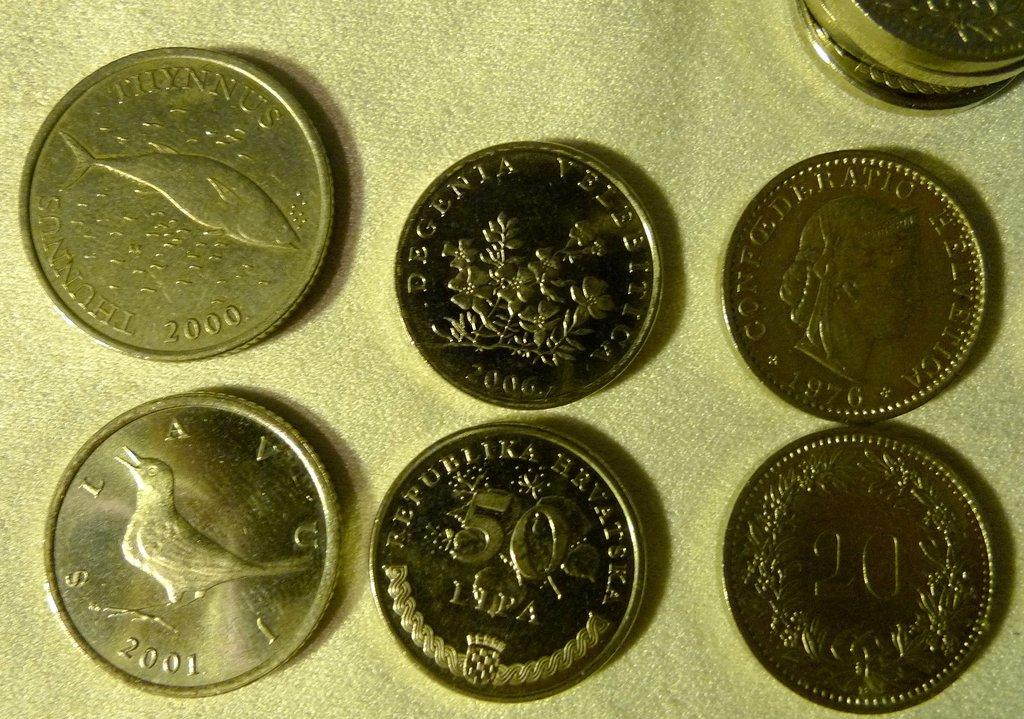<image>
Offer a succinct explanation of the picture presented. Various coins are displayed with years such as 2001 and 2000. 